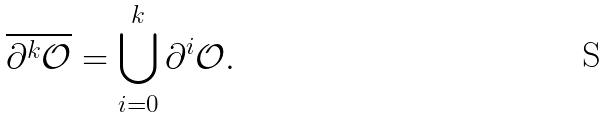<formula> <loc_0><loc_0><loc_500><loc_500>\overline { \partial ^ { k } \mathcal { O } } = \bigcup _ { i = 0 } ^ { k } \partial ^ { i } \mathcal { O } .</formula> 